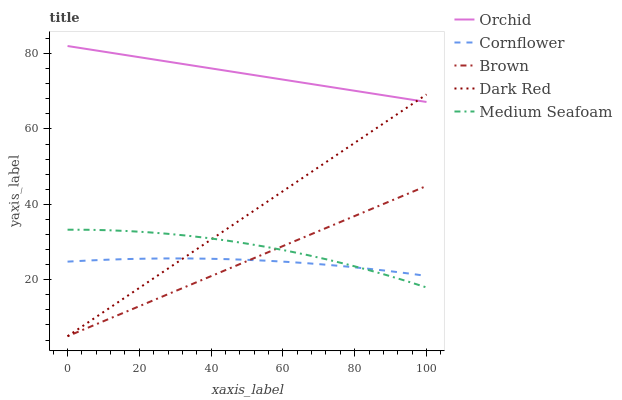Does Cornflower have the minimum area under the curve?
Answer yes or no. Yes. Does Orchid have the maximum area under the curve?
Answer yes or no. Yes. Does Medium Seafoam have the minimum area under the curve?
Answer yes or no. No. Does Medium Seafoam have the maximum area under the curve?
Answer yes or no. No. Is Brown the smoothest?
Answer yes or no. Yes. Is Medium Seafoam the roughest?
Answer yes or no. Yes. Is Dark Red the smoothest?
Answer yes or no. No. Is Dark Red the roughest?
Answer yes or no. No. Does Medium Seafoam have the lowest value?
Answer yes or no. No. Does Orchid have the highest value?
Answer yes or no. Yes. Does Medium Seafoam have the highest value?
Answer yes or no. No. Is Medium Seafoam less than Orchid?
Answer yes or no. Yes. Is Orchid greater than Cornflower?
Answer yes or no. Yes. Does Dark Red intersect Cornflower?
Answer yes or no. Yes. Is Dark Red less than Cornflower?
Answer yes or no. No. Is Dark Red greater than Cornflower?
Answer yes or no. No. Does Medium Seafoam intersect Orchid?
Answer yes or no. No. 